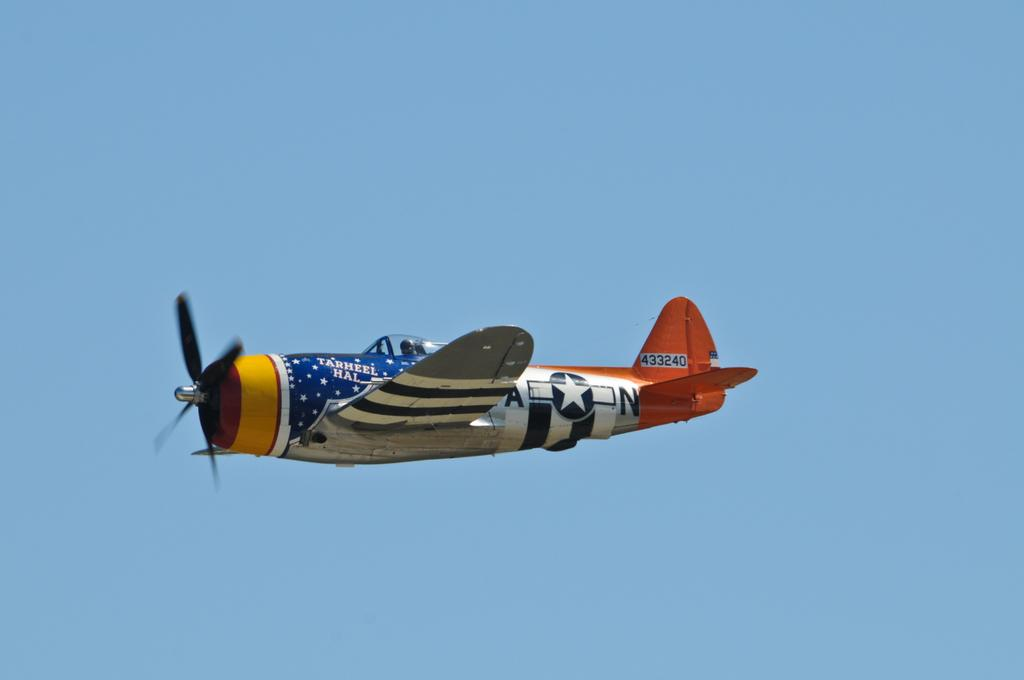What is the main subject of the picture? The main subject of the picture is a jet plane. What can be seen in the background of the image? The sky in the background is blue. What type of creature is standing on the wings of the jet plane in the image? There is no creature present on the wings of the jet plane in the image. How many feet are visible on the ground in the image? There is no reference to feet or any ground in the image, as it features a jet plane against a blue sky. 